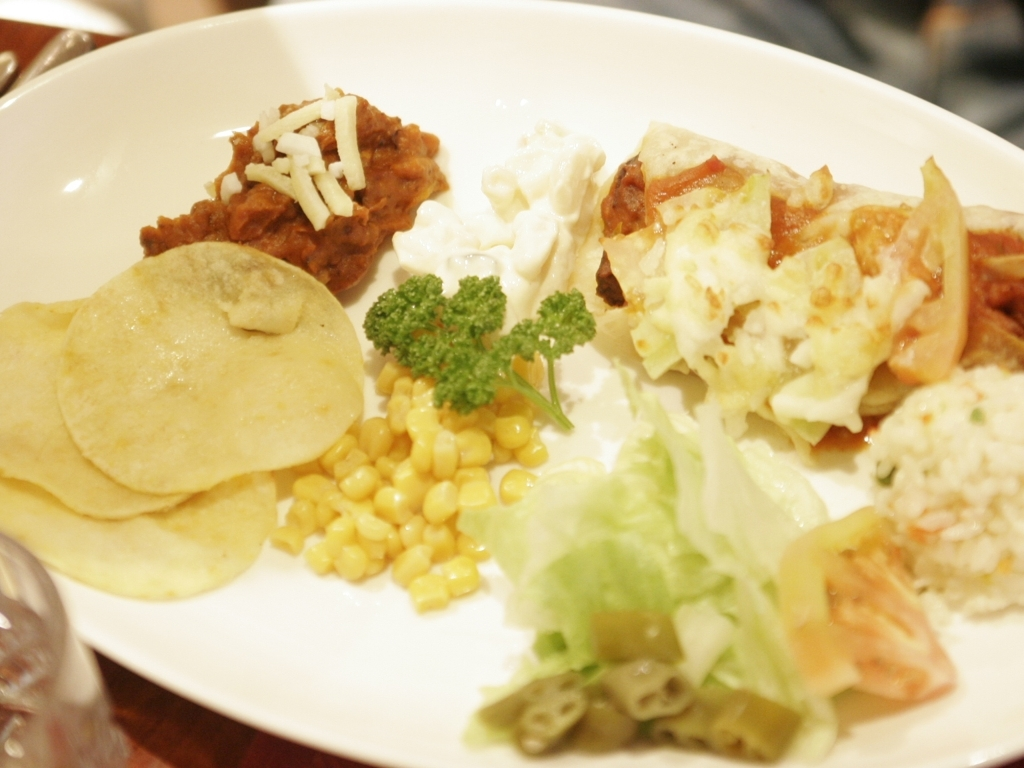Does the photo have a good composition? The composition of the photo is fairly balanced with a variety of elements dispersed across the plate, creating an inviting array of textures and colors. However, it could be improved with better focus and perhaps a clearer emphasis on one of the dish's components to create a focal point. 